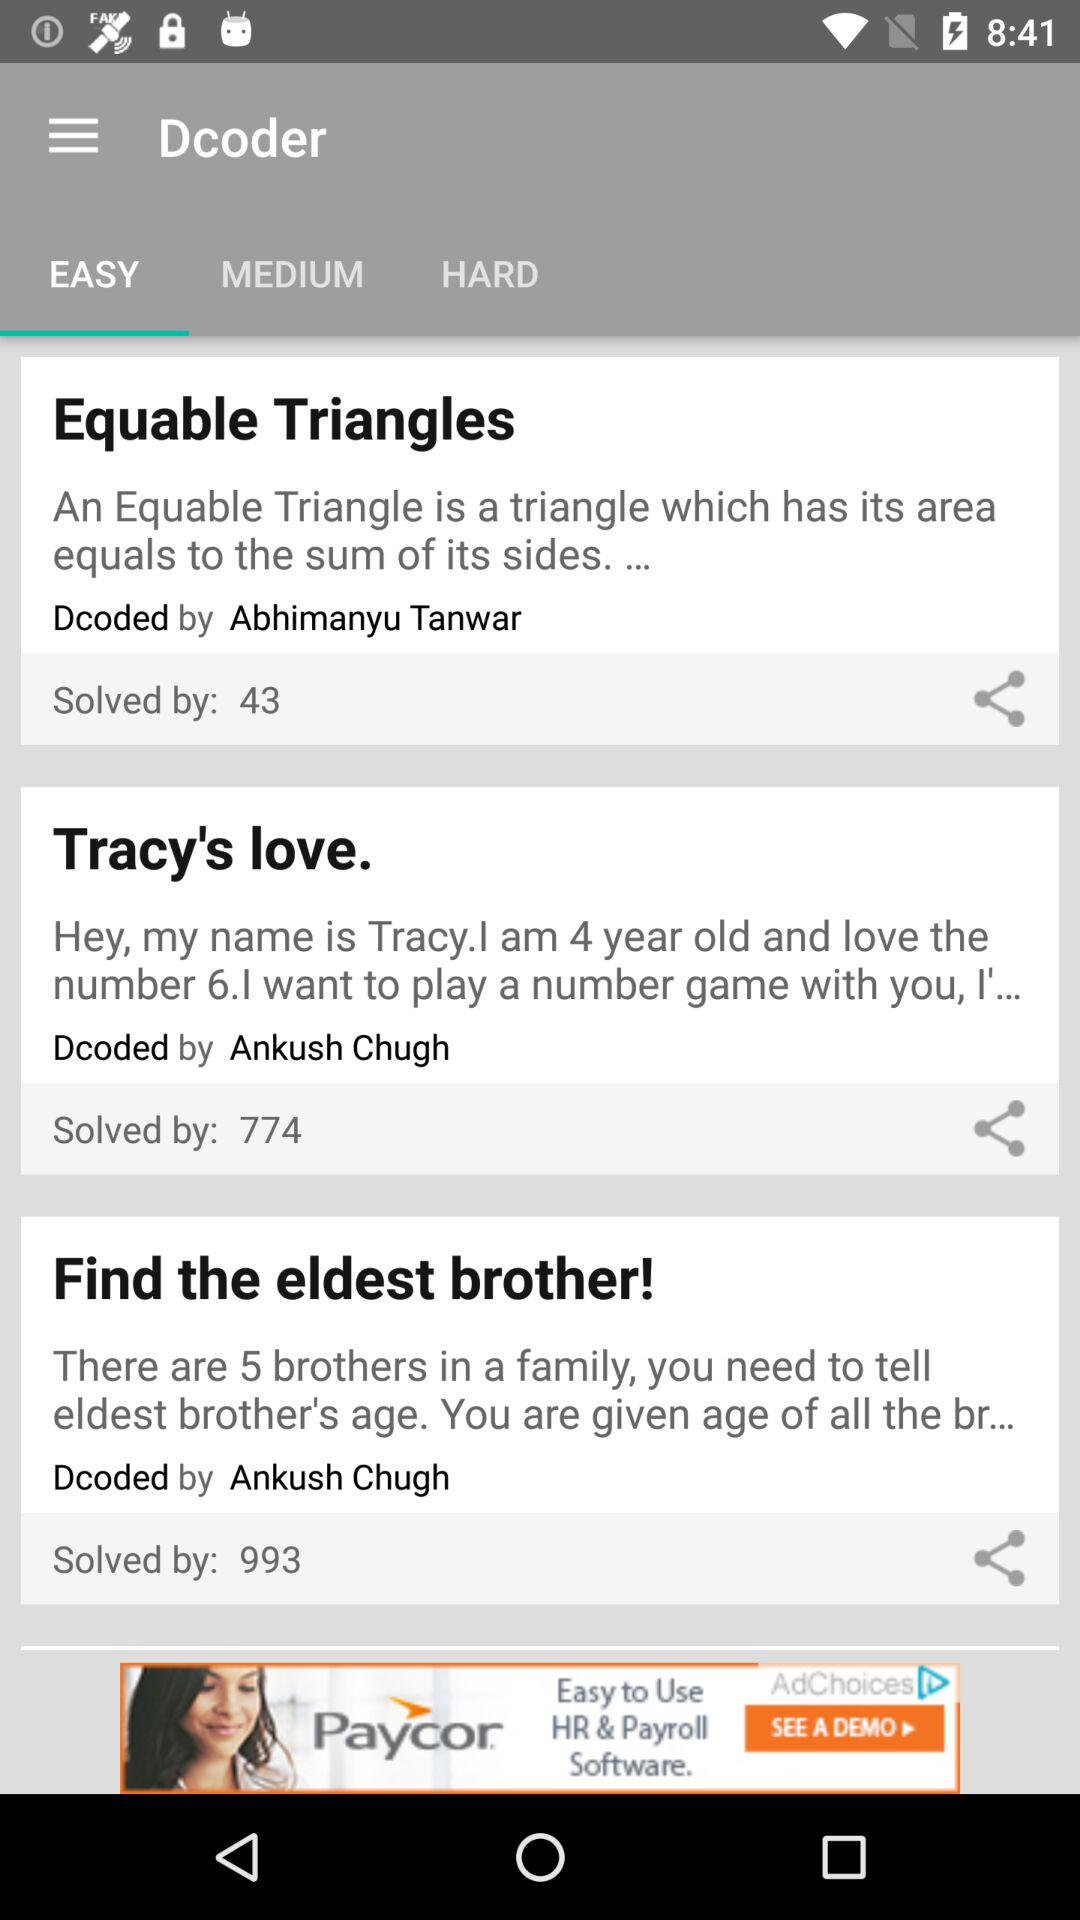What is the name of the decoder for "Find the eldest brother!"? The name of the decoder is Ankush Chugh. 